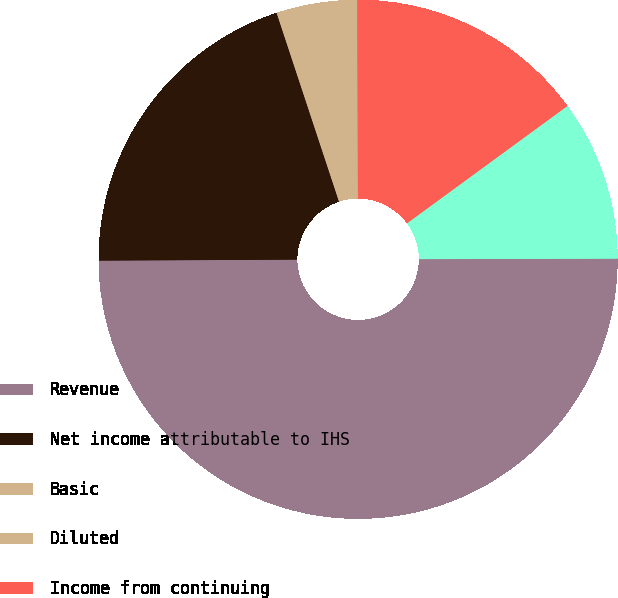<chart> <loc_0><loc_0><loc_500><loc_500><pie_chart><fcel>Revenue<fcel>Net income attributable to IHS<fcel>Basic<fcel>Diluted<fcel>Income from continuing<fcel>Income from discontinued<nl><fcel>49.96%<fcel>20.0%<fcel>5.01%<fcel>0.02%<fcel>15.0%<fcel>10.01%<nl></chart> 